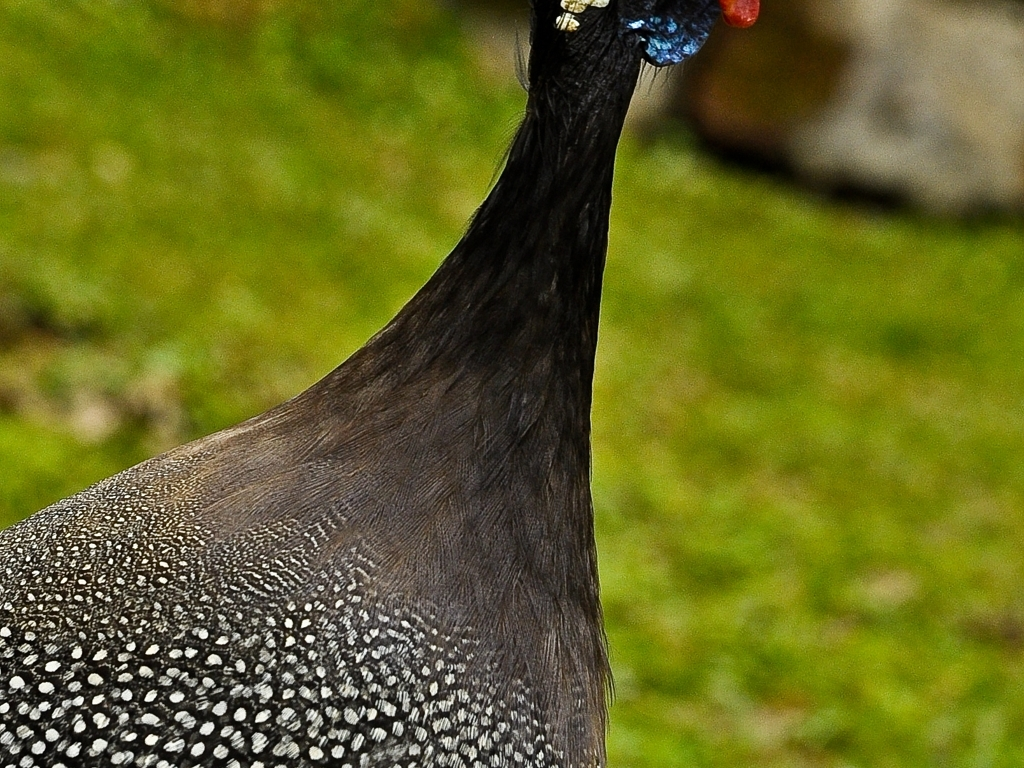Can you describe the coloration of the peacock in this image? The peacock in this image showcases a stunning array of grays and black, peppered with white spots throughout its plumage, which are typical of the species' intricate pattern. Notably, the head features vivid and contrasting hues of blue, red, and an iridescent blue-green, characteristic of the peacock's spectacular crest and face. 